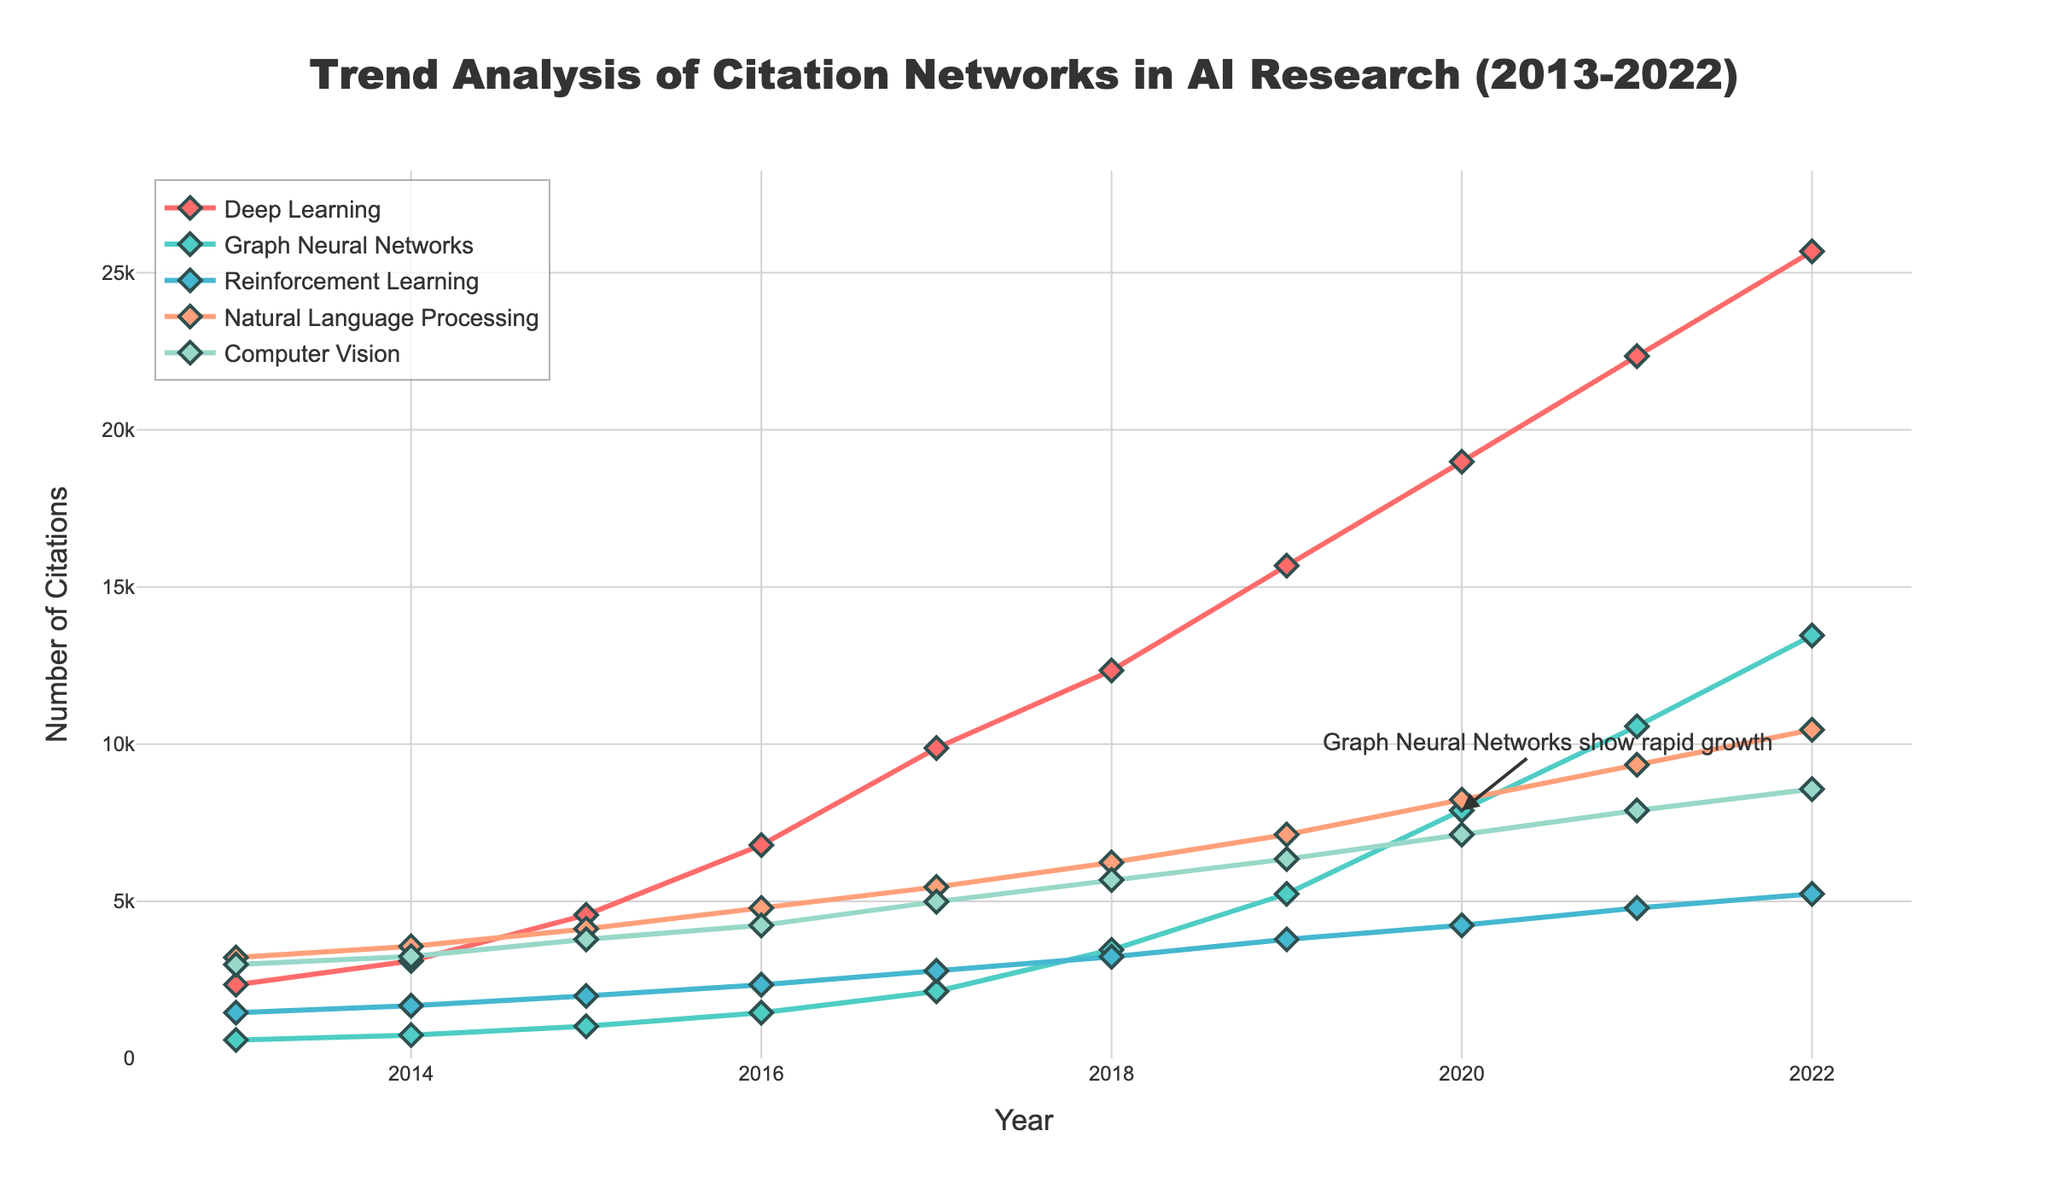Which topic had the highest number of citations in 2022? The highest point on the right end of the graph, across all lines, represents the highest number of citations in 2022. Compare each topic line to find the highest.
Answer: Deep Learning By how much did Graph Neural Networks citations increase from 2016 to 2022? Look at the citation numbers for Graph Neural Networks in 2016 and 2022, then subtract the 2016 value from the 2022 value.
Answer: 12000 In which year did Natural Language Processing citations surpass 5000 for the first time? Locate the point on the Natural Language Processing line that first exceeds 5000 and note the corresponding year.
Answer: 2018 Compare the citation counts of Computer Vision and Reinforcement Learning in 2017, which had more? Locate the 2017 data points for both Computer Vision and Reinforcement Learning, then compare the heights of the markers.
Answer: Computer Vision What is the average number of citations for Deep Learning from 2013 to 2017? Sum the Deep Learning citations from 2013 to 2017 and divide by the number of years (5).
Answer: 5335.8 Which research topic showed the most rapid increase in citations between consecutive years? Identify the largest vertical leap between any two consecutive years across all topics by looking at the steepest line sections.
Answer: Deep Learning between 2013 and 2014 Did any topic have more than 10,000 citations in 2019? If so, which? Check the citation values for all topics in 2019 to see if any exceed 10,000.
Answer: Yes, Deep Learning What is the trend of Reinforcement Learning citations from 2013 to 2022? Observe the overall direction of the Reinforcement Learning line from 2013 to 2022, noting any major increases or decreases.
Answer: Increasing How many research topics surpassed 7000 citations in 2020? Count the number of topics for which the 2020 data point is above 7000 citations.
Answer: Four Which year showed the most significant rise in citations for Graph Neural Networks compared to the previous year? Find the year-to-year differences in Graph Neural Networks citations and identify the largest increase.
Answer: 2020 